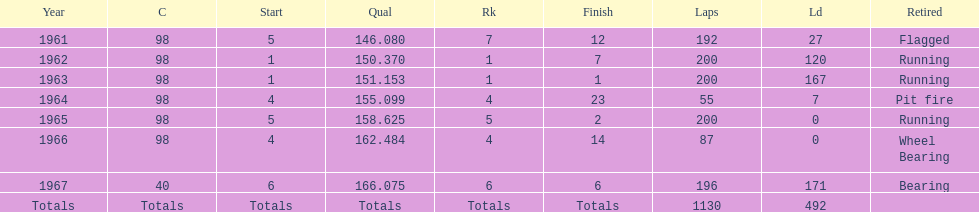What car ranked #1 from 1962-1963? 98. 